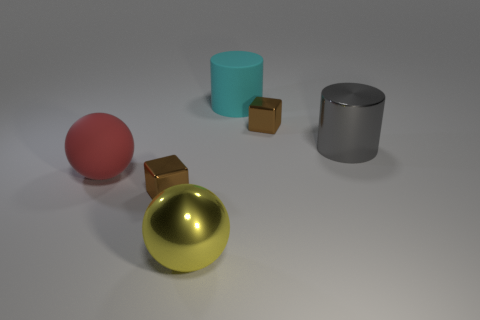Subtract all brown blocks. How many were subtracted if there are1brown blocks left? 1 Add 4 large cylinders. How many objects exist? 10 Subtract all cylinders. How many objects are left? 4 Subtract 0 brown cylinders. How many objects are left? 6 Subtract all cyan rubber things. Subtract all yellow shiny balls. How many objects are left? 4 Add 4 big metal balls. How many big metal balls are left? 5 Add 3 big gray cylinders. How many big gray cylinders exist? 4 